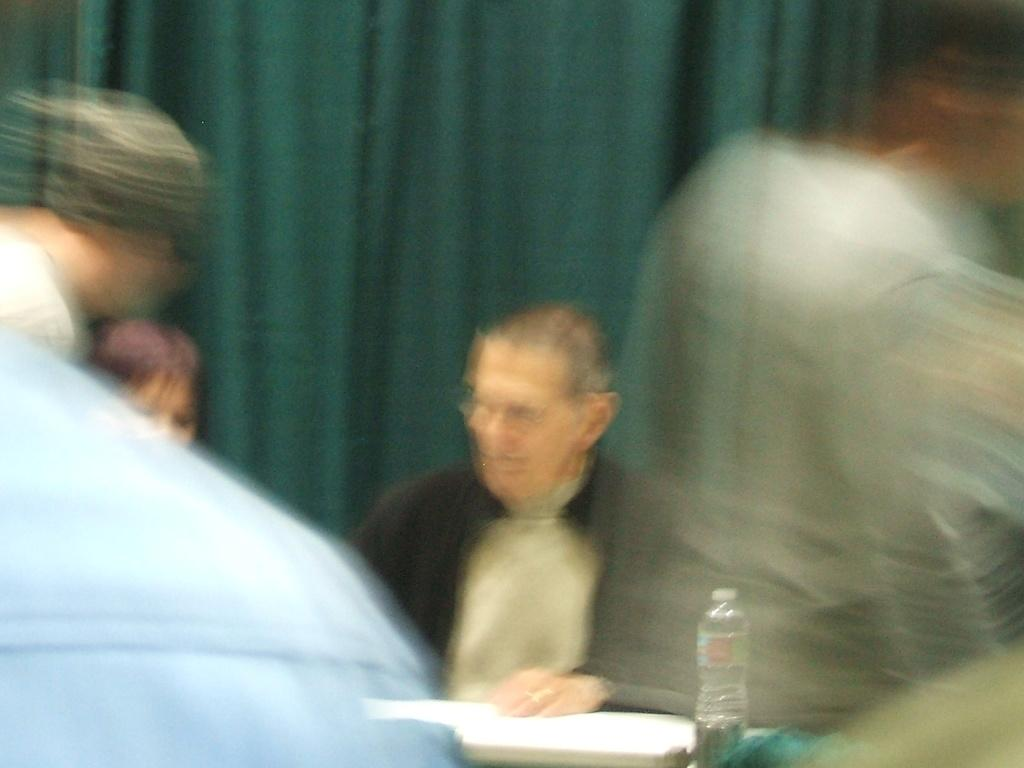What can be observed about the quality of the image? The image is blurry. Can you describe the subjects in the image? There are people in the image. What is the man in the image doing? The man is sitting at a table. What object is on the table with the man? There is a water bottle on the table. What type of suit is the man wearing in the image? There is no information about the man's clothing in the image, so we cannot determine if he is wearing a suit or not. How many apples are on the table in the image? There is no mention of apples in the image, so we cannot determine if there are any apples present. 